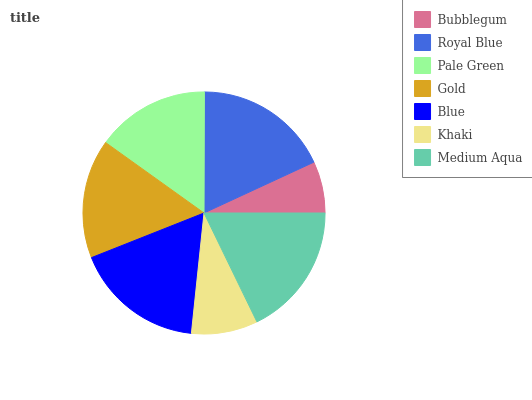Is Bubblegum the minimum?
Answer yes or no. Yes. Is Royal Blue the maximum?
Answer yes or no. Yes. Is Pale Green the minimum?
Answer yes or no. No. Is Pale Green the maximum?
Answer yes or no. No. Is Royal Blue greater than Pale Green?
Answer yes or no. Yes. Is Pale Green less than Royal Blue?
Answer yes or no. Yes. Is Pale Green greater than Royal Blue?
Answer yes or no. No. Is Royal Blue less than Pale Green?
Answer yes or no. No. Is Gold the high median?
Answer yes or no. Yes. Is Gold the low median?
Answer yes or no. Yes. Is Blue the high median?
Answer yes or no. No. Is Blue the low median?
Answer yes or no. No. 